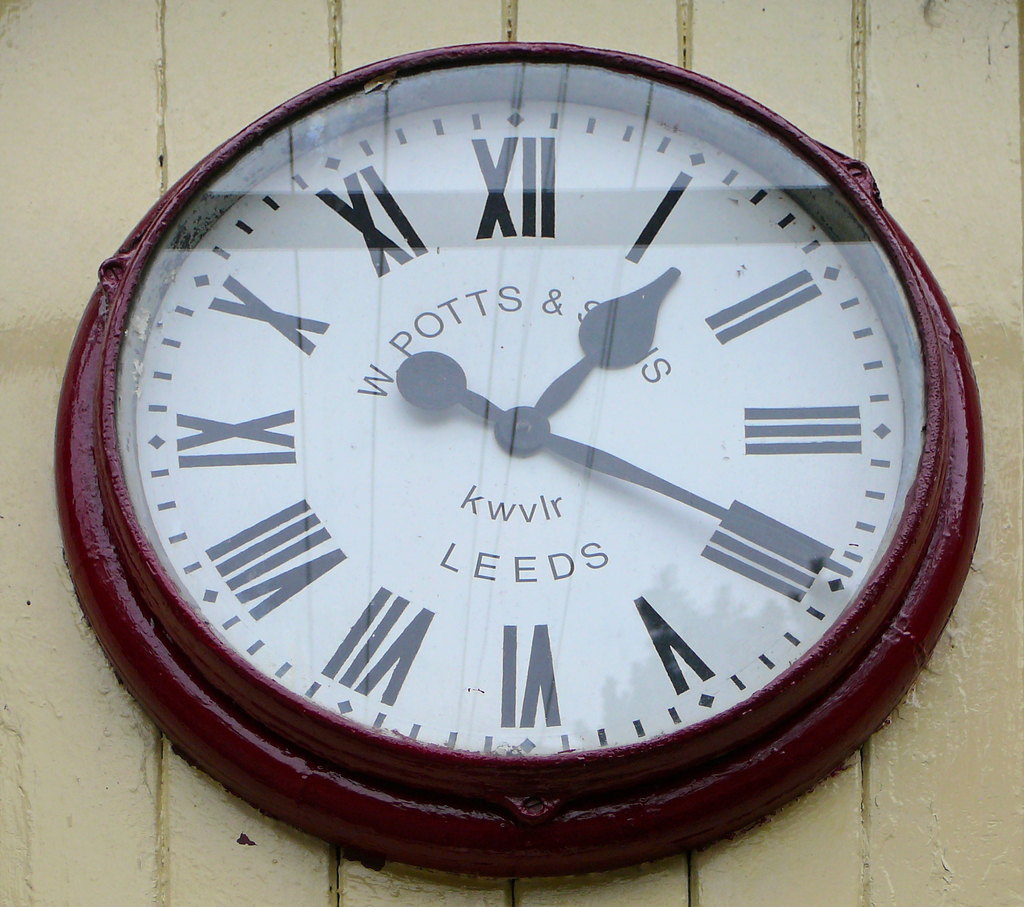How might the weather have affected this clock? The weather has left marks of wear on the clock face, with potential fading of the paint on the numbers and hands as well as visible rust on the metal components, indicating it has withstood many seasons outdoors. 